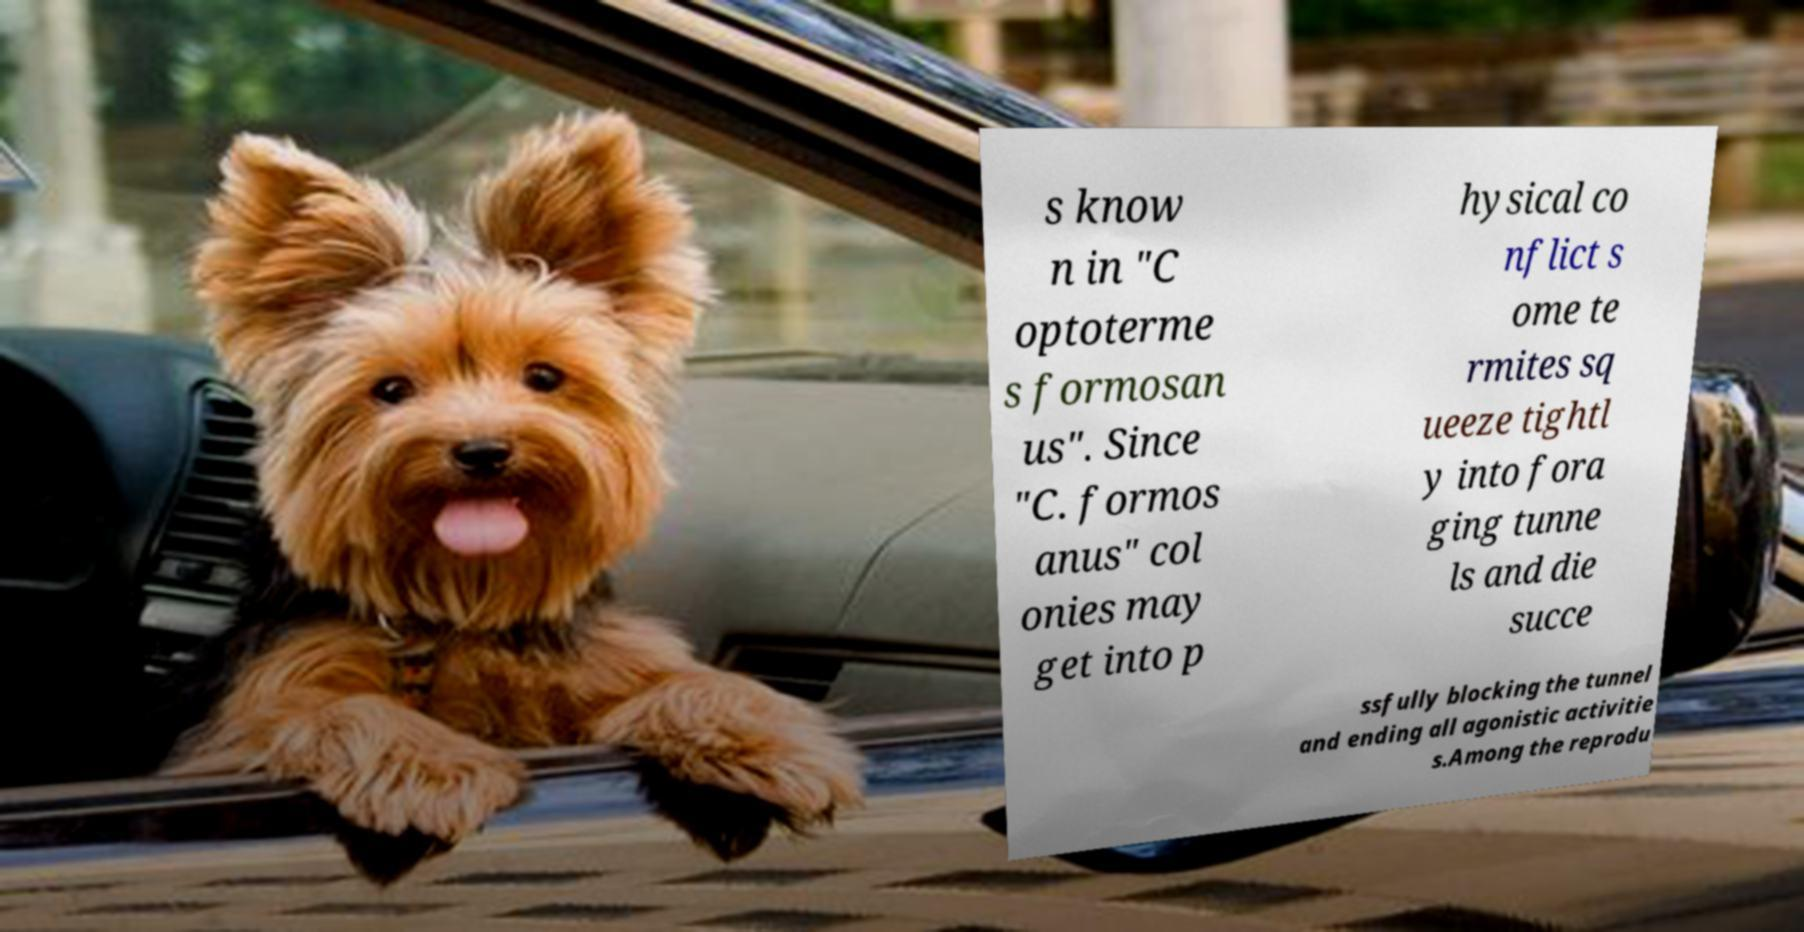There's text embedded in this image that I need extracted. Can you transcribe it verbatim? s know n in "C optoterme s formosan us". Since "C. formos anus" col onies may get into p hysical co nflict s ome te rmites sq ueeze tightl y into fora ging tunne ls and die succe ssfully blocking the tunnel and ending all agonistic activitie s.Among the reprodu 